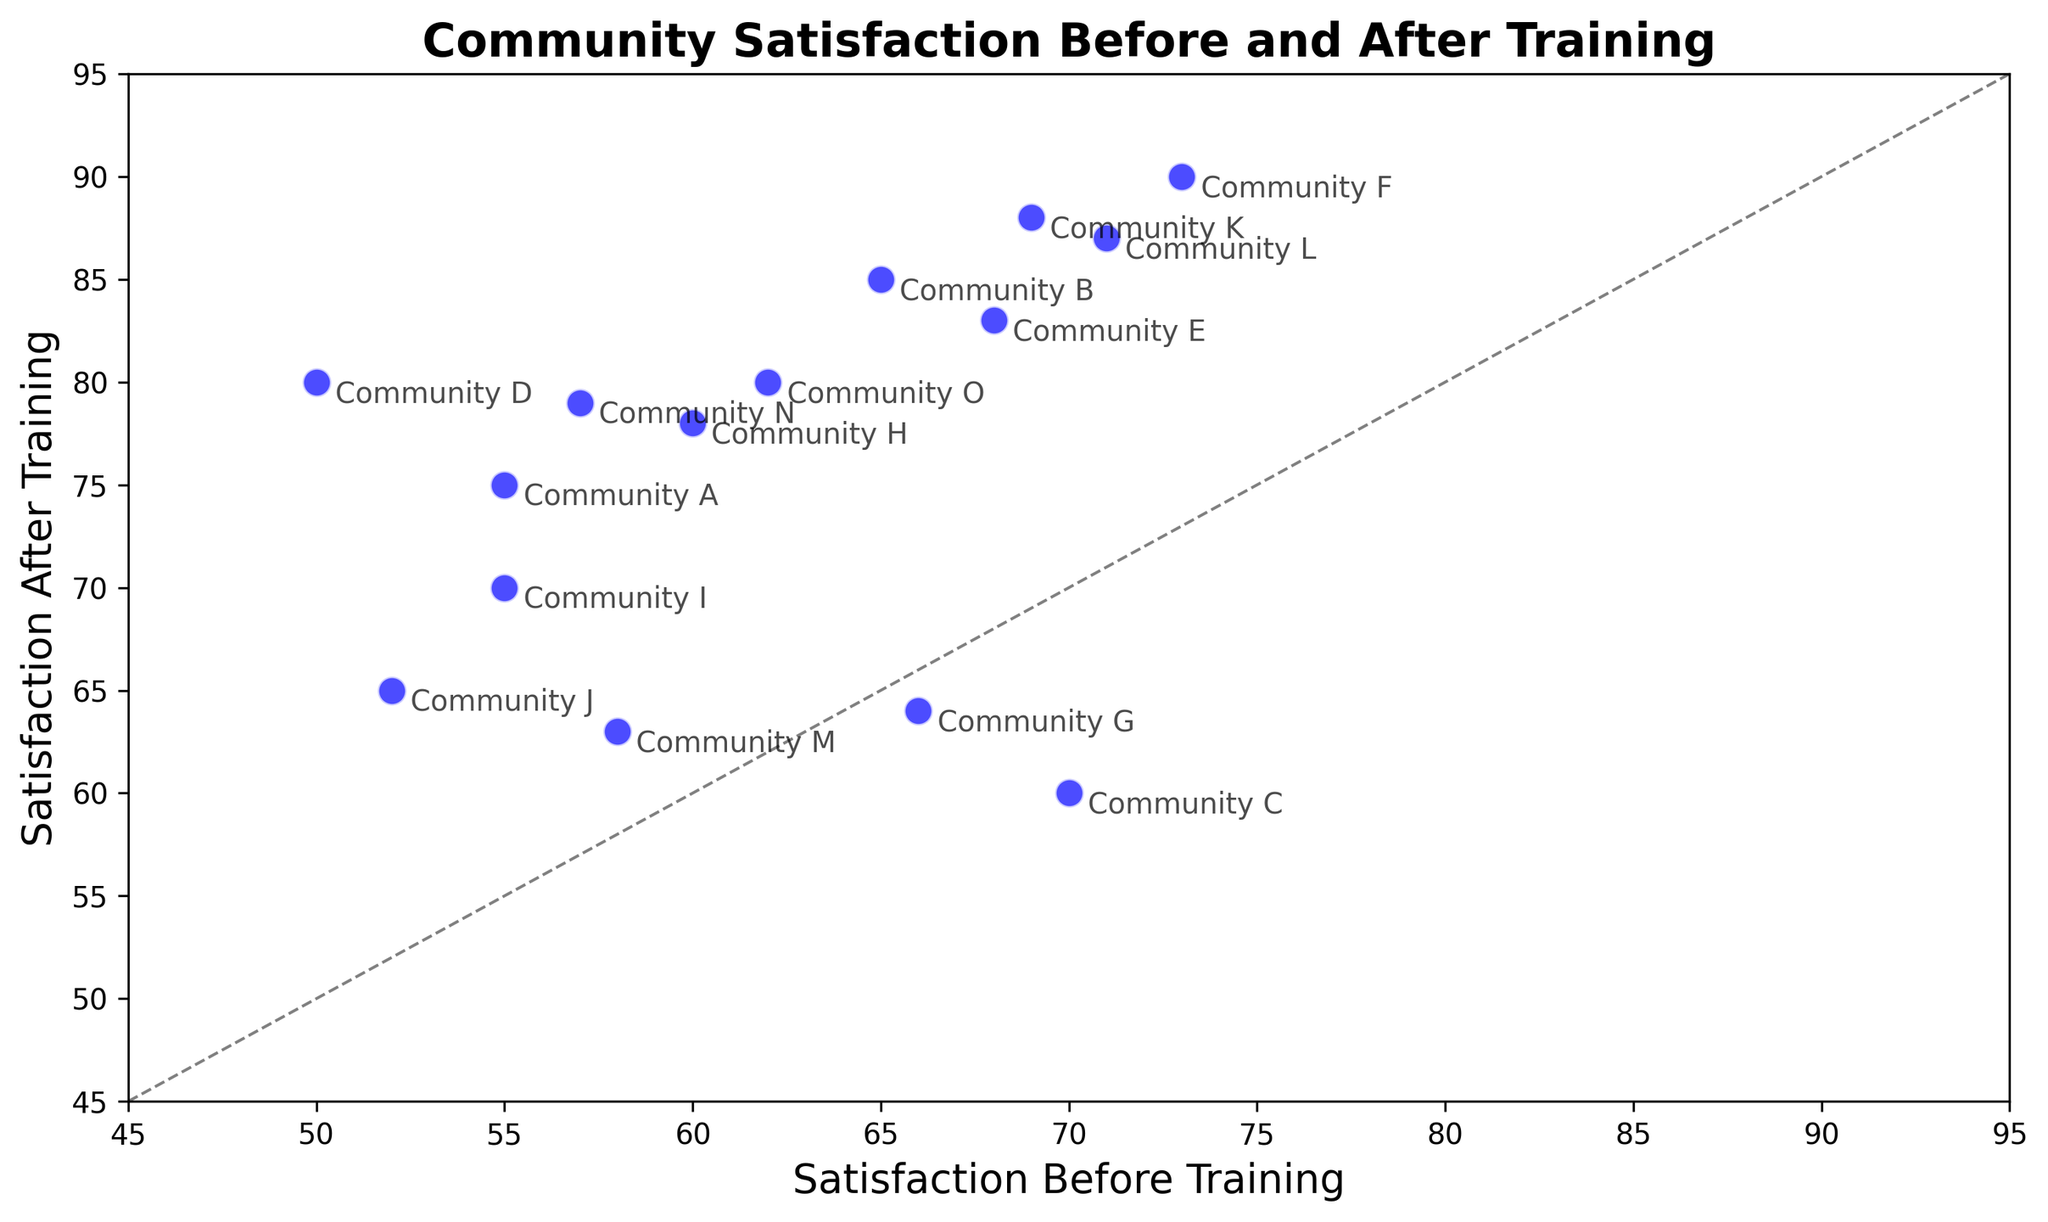Which community had the largest increase in satisfaction score? To determine the largest increase, subtract the 'satisfaction_before' score from the 'satisfaction_after' score for each community and compare the differences. Here, Community F had the largest increase: 90 - 73 = 17.
Answer: Community F Which community had a decrease in satisfaction score after training? Look for communities where 'satisfaction_after' is less than 'satisfaction_before'. Community C and Community G fit this criterion: 60 < 70 and 64 < 66.
Answer: Community C, Community G What is the average satisfaction score before the training for all communities? Sum the 'satisfaction_before' scores for all communities and divide by the number of communities: (55 + 65 + 70 + 50 + 68 + 73 + 66 + 60 + 55 + 52 + 69 + 71 + 58 + 57 + 62) / 15 = 945 / 15 = 63.
Answer: 63 Which community's satisfaction score before training was closest to their score after training? Calculate the absolute difference between 'satisfaction_before' and 'satisfaction_after' for each community and find the smallest difference. Community M has the smallest difference:
Answer: Community M Did any communities not show any improvement after the training? Check if 'satisfaction_after' is greater than 'satisfaction_before' for each community. Communities that did not show improvement are Community C and Community G.
Answer: Community C, Community G 